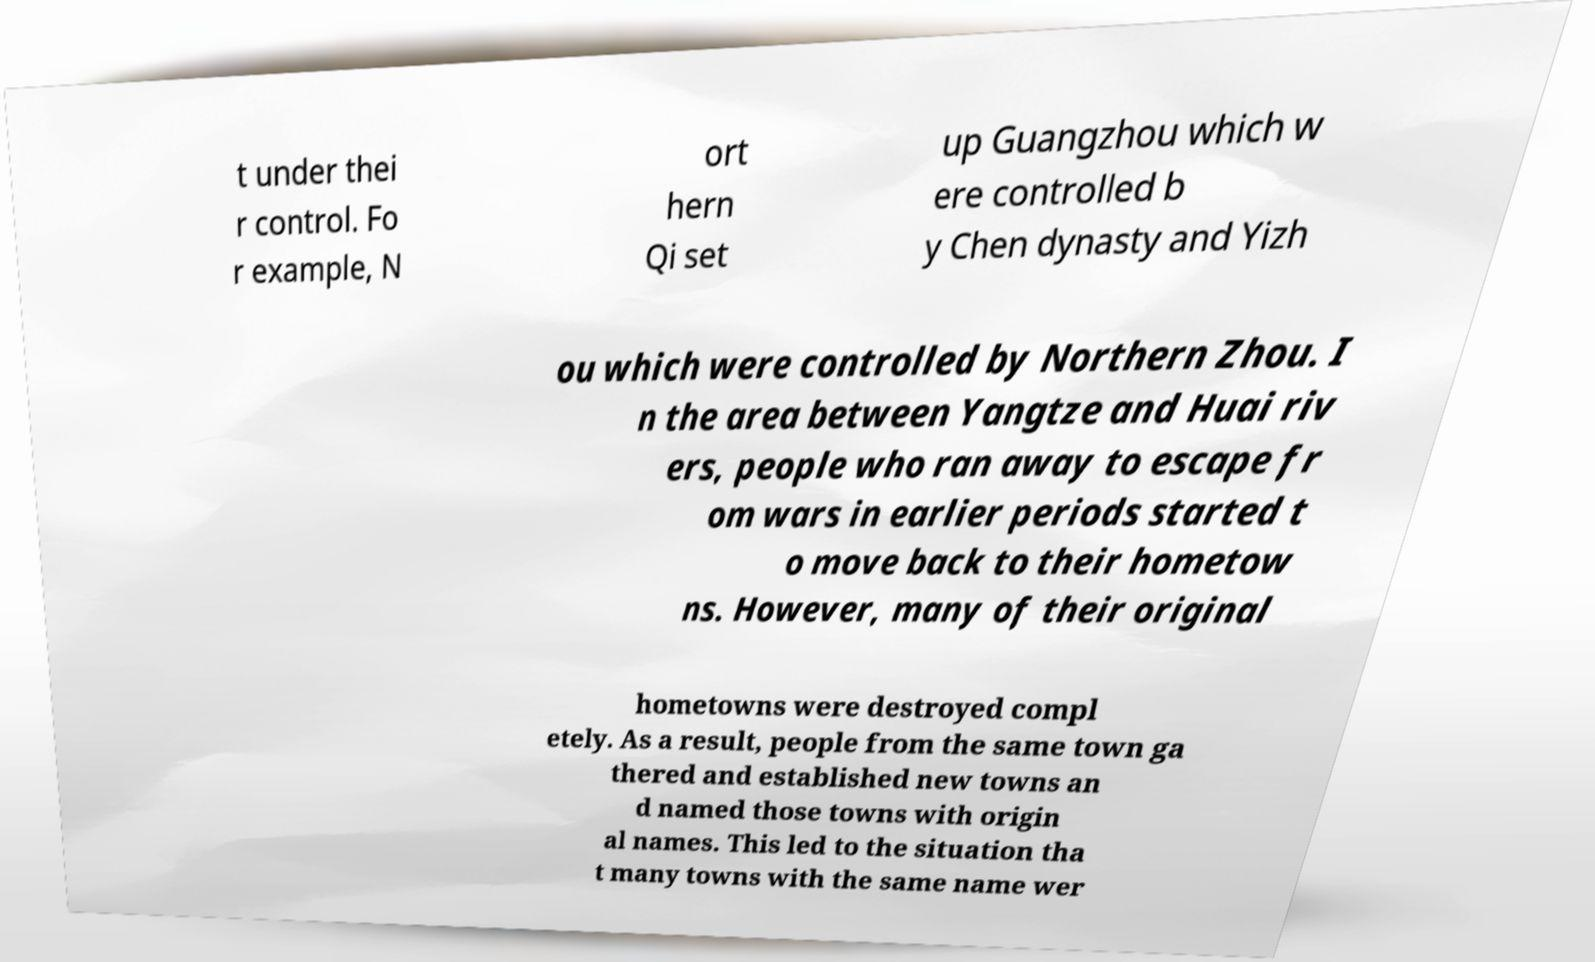There's text embedded in this image that I need extracted. Can you transcribe it verbatim? t under thei r control. Fo r example, N ort hern Qi set up Guangzhou which w ere controlled b y Chen dynasty and Yizh ou which were controlled by Northern Zhou. I n the area between Yangtze and Huai riv ers, people who ran away to escape fr om wars in earlier periods started t o move back to their hometow ns. However, many of their original hometowns were destroyed compl etely. As a result, people from the same town ga thered and established new towns an d named those towns with origin al names. This led to the situation tha t many towns with the same name wer 